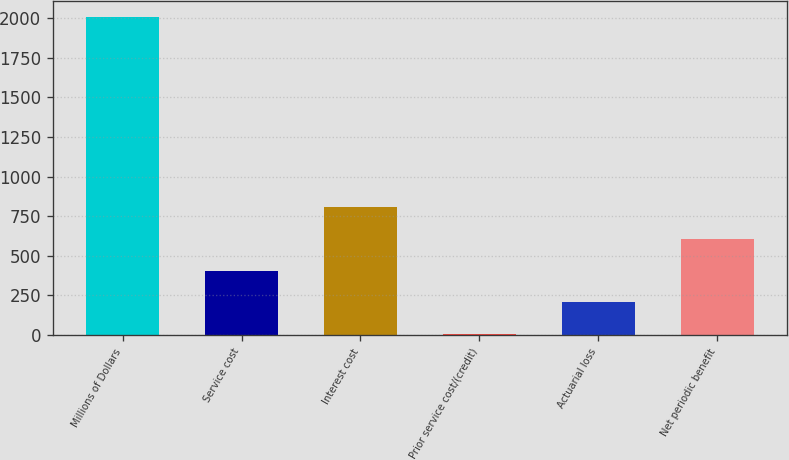Convert chart to OTSL. <chart><loc_0><loc_0><loc_500><loc_500><bar_chart><fcel>Millions of Dollars<fcel>Service cost<fcel>Interest cost<fcel>Prior service cost/(credit)<fcel>Actuarial loss<fcel>Net periodic benefit<nl><fcel>2006<fcel>406.8<fcel>806.6<fcel>7<fcel>206.9<fcel>606.7<nl></chart> 